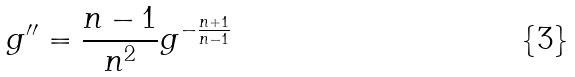Convert formula to latex. <formula><loc_0><loc_0><loc_500><loc_500>g ^ { \prime \prime } = \frac { n - 1 } { n ^ { 2 } } g ^ { - \frac { n + 1 } { n - 1 } }</formula> 